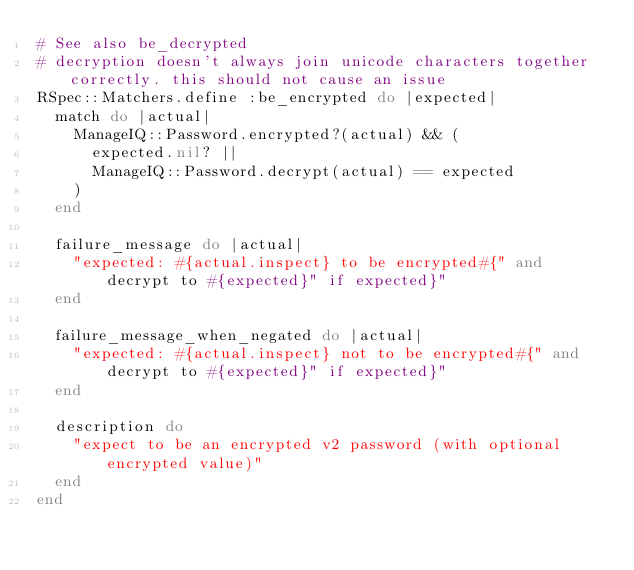<code> <loc_0><loc_0><loc_500><loc_500><_Ruby_># See also be_decrypted
# decryption doesn't always join unicode characters together correctly. this should not cause an issue
RSpec::Matchers.define :be_encrypted do |expected|
  match do |actual|
    ManageIQ::Password.encrypted?(actual) && (
      expected.nil? ||
      ManageIQ::Password.decrypt(actual) == expected
    )
  end

  failure_message do |actual|
    "expected: #{actual.inspect} to be encrypted#{" and decrypt to #{expected}" if expected}"
  end

  failure_message_when_negated do |actual|
    "expected: #{actual.inspect} not to be encrypted#{" and decrypt to #{expected}" if expected}"
  end

  description do
    "expect to be an encrypted v2 password (with optional encrypted value)"
  end
end
</code> 